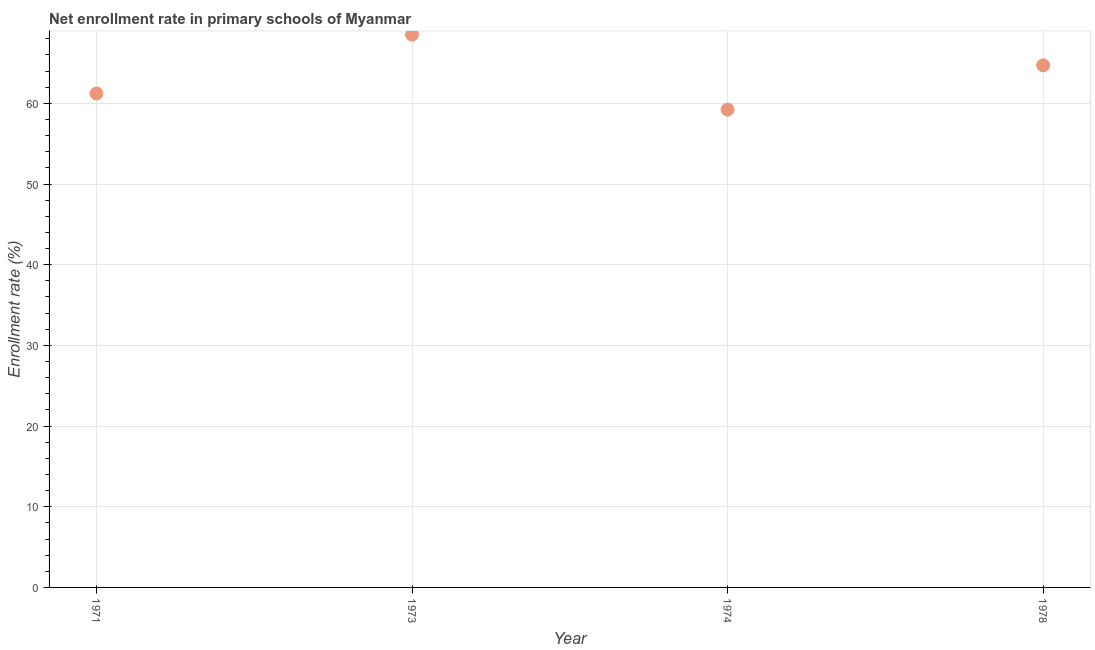What is the net enrollment rate in primary schools in 1973?
Keep it short and to the point. 68.52. Across all years, what is the maximum net enrollment rate in primary schools?
Ensure brevity in your answer.  68.52. Across all years, what is the minimum net enrollment rate in primary schools?
Keep it short and to the point. 59.22. In which year was the net enrollment rate in primary schools maximum?
Your answer should be very brief. 1973. In which year was the net enrollment rate in primary schools minimum?
Offer a very short reply. 1974. What is the sum of the net enrollment rate in primary schools?
Offer a terse response. 253.68. What is the difference between the net enrollment rate in primary schools in 1973 and 1978?
Offer a very short reply. 3.82. What is the average net enrollment rate in primary schools per year?
Your answer should be very brief. 63.42. What is the median net enrollment rate in primary schools?
Your answer should be very brief. 62.97. Do a majority of the years between 1973 and 1974 (inclusive) have net enrollment rate in primary schools greater than 8 %?
Your response must be concise. Yes. What is the ratio of the net enrollment rate in primary schools in 1974 to that in 1978?
Provide a short and direct response. 0.92. What is the difference between the highest and the second highest net enrollment rate in primary schools?
Make the answer very short. 3.82. What is the difference between the highest and the lowest net enrollment rate in primary schools?
Make the answer very short. 9.3. In how many years, is the net enrollment rate in primary schools greater than the average net enrollment rate in primary schools taken over all years?
Provide a short and direct response. 2. Does the net enrollment rate in primary schools monotonically increase over the years?
Your answer should be compact. No. How many dotlines are there?
Offer a terse response. 1. Are the values on the major ticks of Y-axis written in scientific E-notation?
Your response must be concise. No. What is the title of the graph?
Your response must be concise. Net enrollment rate in primary schools of Myanmar. What is the label or title of the Y-axis?
Provide a succinct answer. Enrollment rate (%). What is the Enrollment rate (%) in 1971?
Provide a succinct answer. 61.23. What is the Enrollment rate (%) in 1973?
Your answer should be compact. 68.52. What is the Enrollment rate (%) in 1974?
Your answer should be compact. 59.22. What is the Enrollment rate (%) in 1978?
Provide a short and direct response. 64.71. What is the difference between the Enrollment rate (%) in 1971 and 1973?
Keep it short and to the point. -7.3. What is the difference between the Enrollment rate (%) in 1971 and 1974?
Your response must be concise. 2.01. What is the difference between the Enrollment rate (%) in 1971 and 1978?
Your response must be concise. -3.48. What is the difference between the Enrollment rate (%) in 1973 and 1974?
Make the answer very short. 9.3. What is the difference between the Enrollment rate (%) in 1973 and 1978?
Ensure brevity in your answer.  3.82. What is the difference between the Enrollment rate (%) in 1974 and 1978?
Provide a succinct answer. -5.49. What is the ratio of the Enrollment rate (%) in 1971 to that in 1973?
Provide a succinct answer. 0.89. What is the ratio of the Enrollment rate (%) in 1971 to that in 1974?
Ensure brevity in your answer.  1.03. What is the ratio of the Enrollment rate (%) in 1971 to that in 1978?
Make the answer very short. 0.95. What is the ratio of the Enrollment rate (%) in 1973 to that in 1974?
Your response must be concise. 1.16. What is the ratio of the Enrollment rate (%) in 1973 to that in 1978?
Offer a terse response. 1.06. What is the ratio of the Enrollment rate (%) in 1974 to that in 1978?
Offer a very short reply. 0.92. 